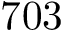<formula> <loc_0><loc_0><loc_500><loc_500>7 0 3</formula> 